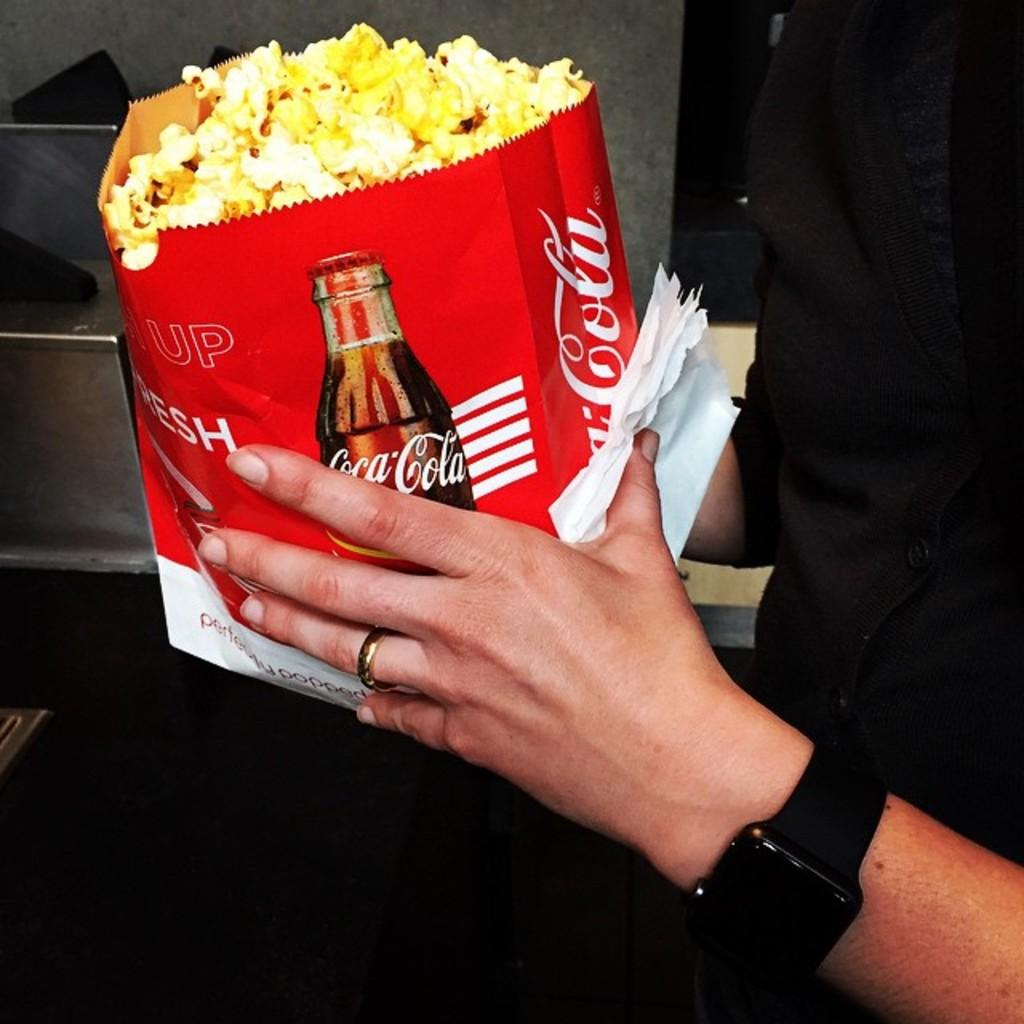Is this a pepsi bag?
Your response must be concise. No. What brand is the bag?
Make the answer very short. Coca cola. 